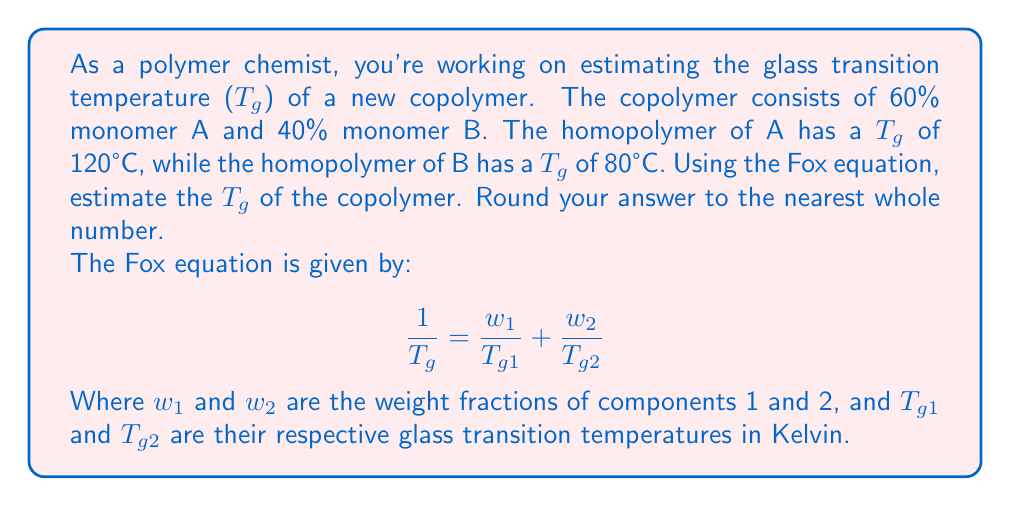Solve this math problem. Let's approach this step-by-step:

1) First, we need to convert the given temperatures from Celsius to Kelvin:
   $T_{g1} = 120°C + 273.15 = 393.15K$
   $T_{g2} = 80°C + 273.15 = 353.15K$

2) We know the weight fractions:
   $w_1 = 0.60$ (for monomer A)
   $w_2 = 0.40$ (for monomer B)

3) Now, let's substitute these values into the Fox equation:

   $$\frac{1}{T_g} = \frac{0.60}{393.15} + \frac{0.40}{353.15}$$

4) Let's calculate each fraction:
   $$\frac{1}{T_g} = 0.001526 + 0.001133 = 0.002659$$

5) To find $T_g$, we need to take the reciprocal of this sum:

   $$T_g = \frac{1}{0.002659} = 376.08K$$

6) Finally, we convert back to Celsius:
   $T_g = 376.08 - 273.15 = 102.93°C$

7) Rounding to the nearest whole number:
   $T_g ≈ 103°C$
Answer: 103°C 